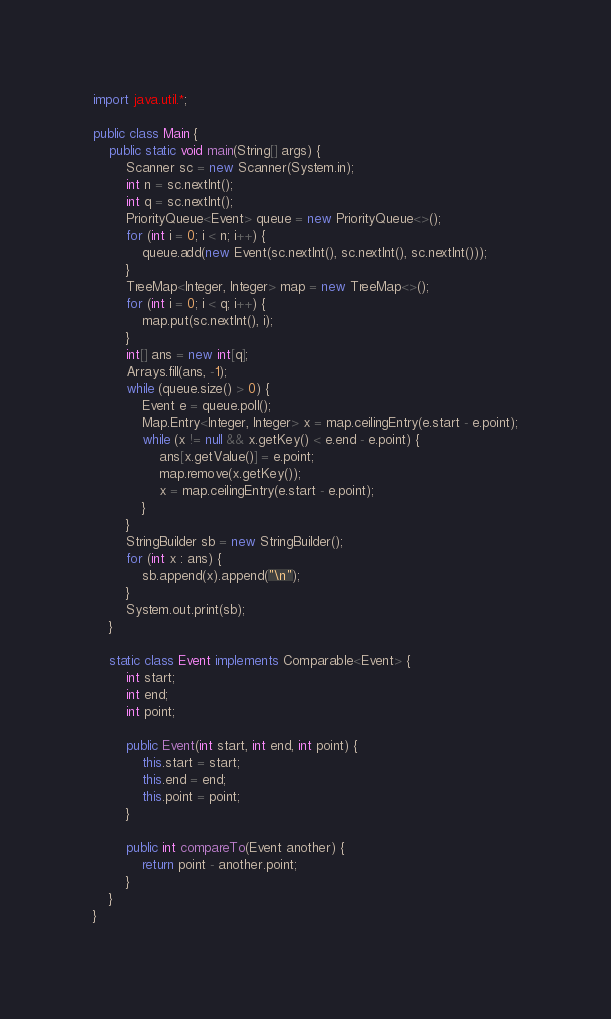Convert code to text. <code><loc_0><loc_0><loc_500><loc_500><_Java_>import java.util.*;

public class Main {
    public static void main(String[] args) {
        Scanner sc = new Scanner(System.in);
        int n = sc.nextInt();
        int q = sc.nextInt();
        PriorityQueue<Event> queue = new PriorityQueue<>();
        for (int i = 0; i < n; i++) {
            queue.add(new Event(sc.nextInt(), sc.nextInt(), sc.nextInt()));
        }
        TreeMap<Integer, Integer> map = new TreeMap<>();
        for (int i = 0; i < q; i++) {
            map.put(sc.nextInt(), i);
        }
        int[] ans = new int[q];
        Arrays.fill(ans, -1);
        while (queue.size() > 0) {
            Event e = queue.poll();
            Map.Entry<Integer, Integer> x = map.ceilingEntry(e.start - e.point);
            while (x != null && x.getKey() < e.end - e.point) {
                ans[x.getValue()] = e.point;
                map.remove(x.getKey());
                x = map.ceilingEntry(e.start - e.point);
            }
        }
        StringBuilder sb = new StringBuilder();
        for (int x : ans) {
            sb.append(x).append("\n");
        }
        System.out.print(sb);
    }
    
    static class Event implements Comparable<Event> {
        int start;
        int end;
        int point;
        
        public Event(int start, int end, int point) {
            this.start = start;
            this.end = end;
            this.point = point;
        }
        
        public int compareTo(Event another) {
            return point - another.point;
        }
    }
}</code> 